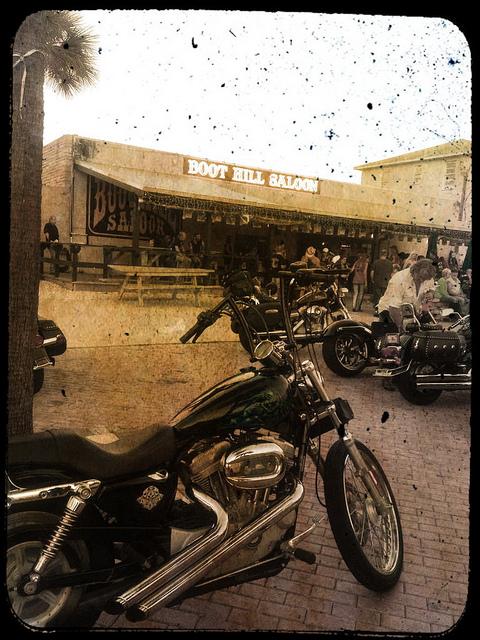What is the name of the saloon?
Be succinct. Boot hill saloon. Is this a grainy photo or is their debris in the air?
Short answer required. Grainy photo. What vehicle is shown?
Be succinct. Motorcycle. What material is the road made of?
Answer briefly. Brick. 